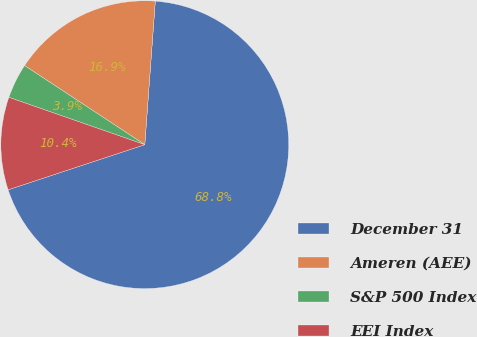<chart> <loc_0><loc_0><loc_500><loc_500><pie_chart><fcel>December 31<fcel>Ameren (AEE)<fcel>S&P 500 Index<fcel>EEI Index<nl><fcel>68.76%<fcel>16.9%<fcel>3.93%<fcel>10.41%<nl></chart> 